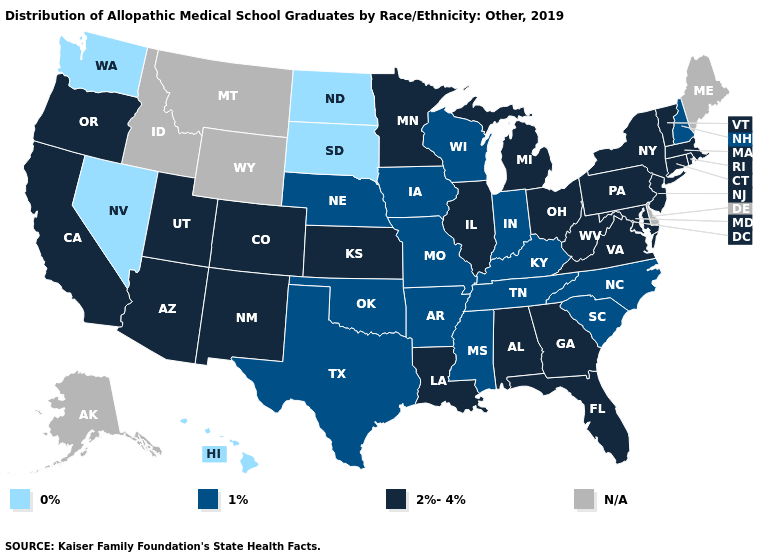Name the states that have a value in the range 0%?
Concise answer only. Hawaii, Nevada, North Dakota, South Dakota, Washington. Name the states that have a value in the range N/A?
Write a very short answer. Alaska, Delaware, Idaho, Maine, Montana, Wyoming. Name the states that have a value in the range 1%?
Write a very short answer. Arkansas, Indiana, Iowa, Kentucky, Mississippi, Missouri, Nebraska, New Hampshire, North Carolina, Oklahoma, South Carolina, Tennessee, Texas, Wisconsin. Does the first symbol in the legend represent the smallest category?
Give a very brief answer. Yes. What is the value of Arkansas?
Concise answer only. 1%. Which states have the lowest value in the MidWest?
Concise answer only. North Dakota, South Dakota. Name the states that have a value in the range 2%-4%?
Quick response, please. Alabama, Arizona, California, Colorado, Connecticut, Florida, Georgia, Illinois, Kansas, Louisiana, Maryland, Massachusetts, Michigan, Minnesota, New Jersey, New Mexico, New York, Ohio, Oregon, Pennsylvania, Rhode Island, Utah, Vermont, Virginia, West Virginia. Which states have the highest value in the USA?
Give a very brief answer. Alabama, Arizona, California, Colorado, Connecticut, Florida, Georgia, Illinois, Kansas, Louisiana, Maryland, Massachusetts, Michigan, Minnesota, New Jersey, New Mexico, New York, Ohio, Oregon, Pennsylvania, Rhode Island, Utah, Vermont, Virginia, West Virginia. What is the lowest value in the South?
Short answer required. 1%. What is the lowest value in the USA?
Concise answer only. 0%. What is the lowest value in states that border Indiana?
Answer briefly. 1%. Which states have the lowest value in the USA?
Answer briefly. Hawaii, Nevada, North Dakota, South Dakota, Washington. What is the value of Montana?
Short answer required. N/A. Does the first symbol in the legend represent the smallest category?
Write a very short answer. Yes. 